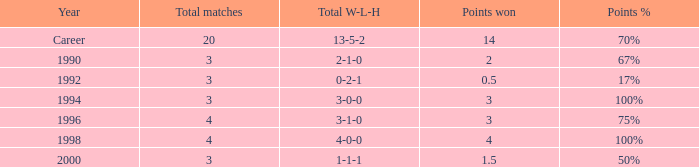Can you tell me the lowest Points won that has the Total matches of 4, and the Total W-L-H of 4-0-0? 4.0. Parse the table in full. {'header': ['Year', 'Total matches', 'Total W-L-H', 'Points won', 'Points %'], 'rows': [['Career', '20', '13-5-2', '14', '70%'], ['1990', '3', '2-1-0', '2', '67%'], ['1992', '3', '0-2-1', '0.5', '17%'], ['1994', '3', '3-0-0', '3', '100%'], ['1996', '4', '3-1-0', '3', '75%'], ['1998', '4', '4-0-0', '4', '100%'], ['2000', '3', '1-1-1', '1.5', '50%']]} 